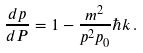<formula> <loc_0><loc_0><loc_500><loc_500>\frac { d p } { d P } & = 1 - \frac { m ^ { 2 } } { p ^ { 2 } p _ { 0 } } \hbar { k } \, .</formula> 